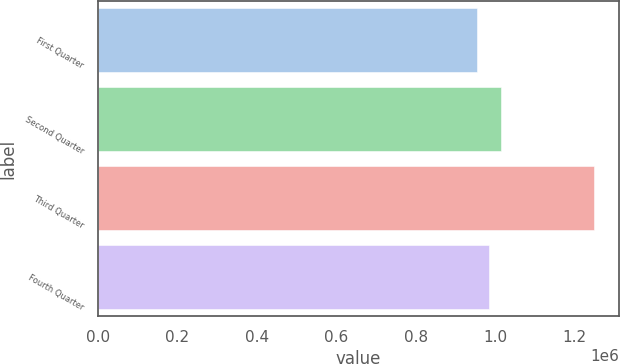Convert chart to OTSL. <chart><loc_0><loc_0><loc_500><loc_500><bar_chart><fcel>First Quarter<fcel>Second Quarter<fcel>Third Quarter<fcel>Fourth Quarter<nl><fcel>955145<fcel>1.01401e+06<fcel>1.24945e+06<fcel>984576<nl></chart> 